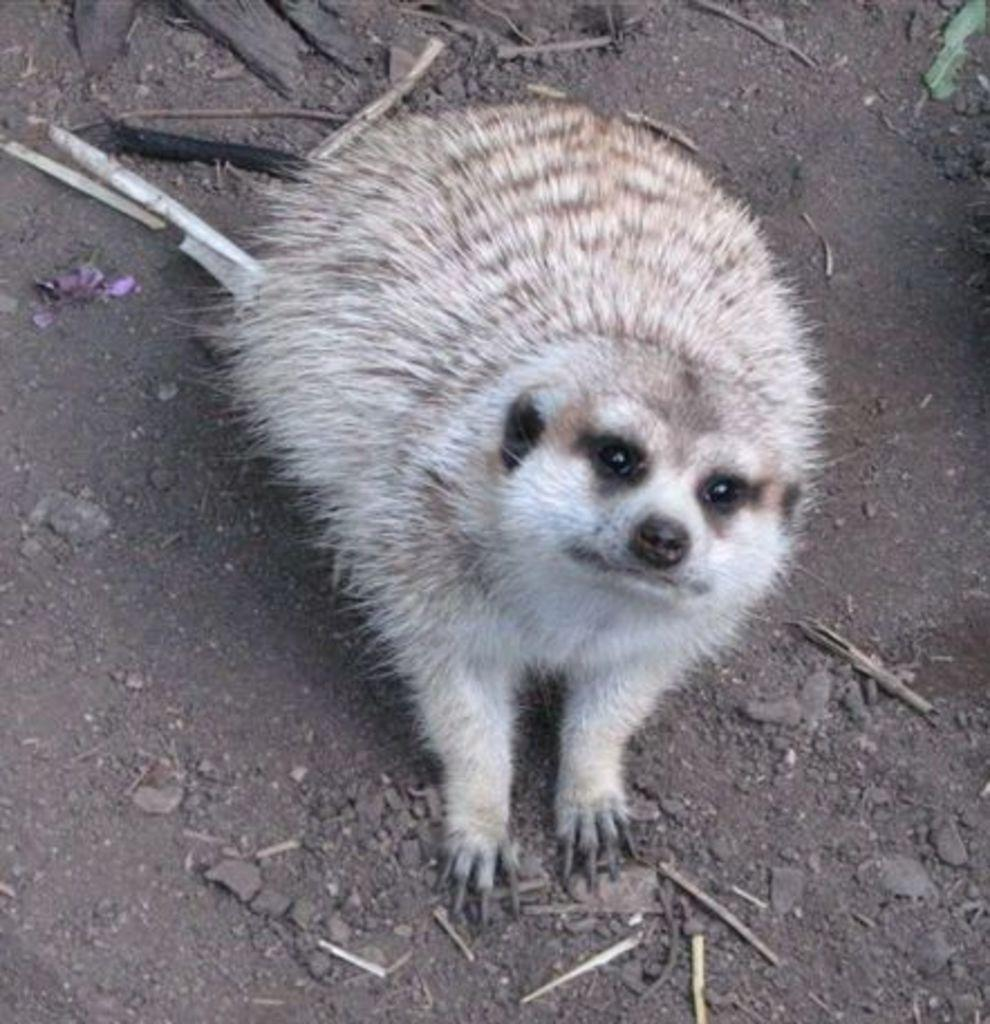Where was the image taken? The image was clicked outside. What is the main subject of the image? There is a white color animal in the center of the image. What is the animal doing in the image? The animal is sitting on the ground. What can be seen in the background of the image? There are items placed in the background of the image. What is the animal's belief about the trick in the room? There is no mention of a trick or a room in the image, so it is not possible to determine the animal's belief about it. 